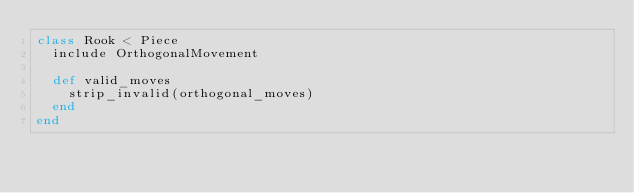Convert code to text. <code><loc_0><loc_0><loc_500><loc_500><_Ruby_>class Rook < Piece
  include OrthogonalMovement

  def valid_moves
    strip_invalid(orthogonal_moves)
  end
end
</code> 